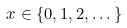<formula> <loc_0><loc_0><loc_500><loc_500>x \in \{ 0 , 1 , 2 , \dots \}</formula> 